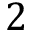<formula> <loc_0><loc_0><loc_500><loc_500>2</formula> 